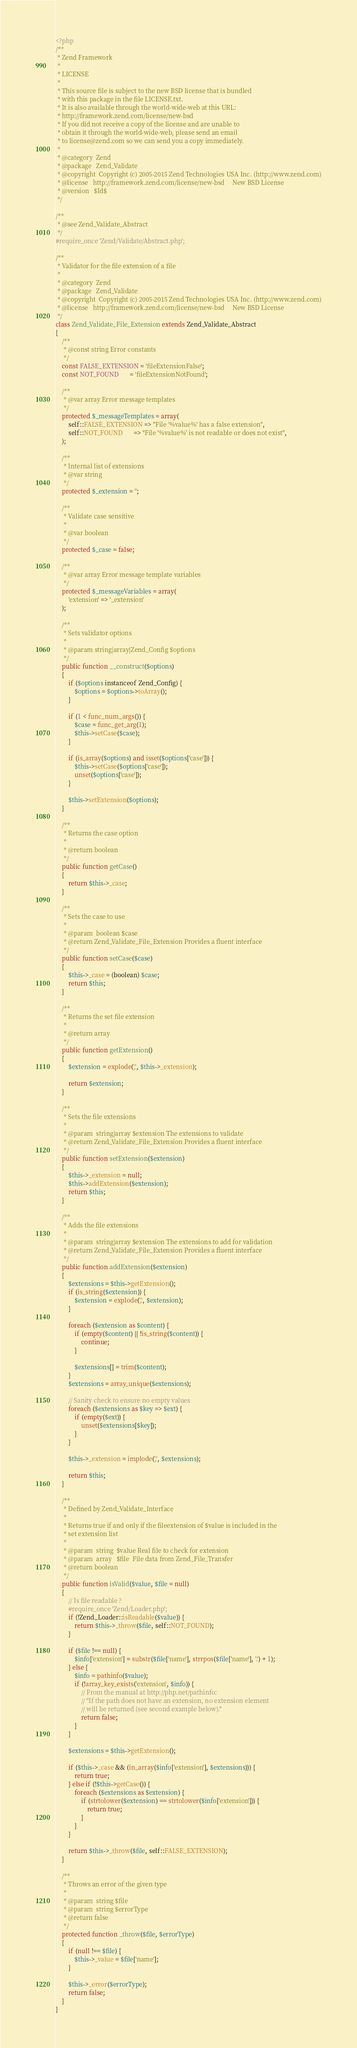Convert code to text. <code><loc_0><loc_0><loc_500><loc_500><_PHP_><?php
/**
 * Zend Framework
 *
 * LICENSE
 *
 * This source file is subject to the new BSD license that is bundled
 * with this package in the file LICENSE.txt.
 * It is also available through the world-wide-web at this URL:
 * http://framework.zend.com/license/new-bsd
 * If you did not receive a copy of the license and are unable to
 * obtain it through the world-wide-web, please send an email
 * to license@zend.com so we can send you a copy immediately.
 *
 * @category  Zend
 * @package   Zend_Validate
 * @copyright  Copyright (c) 2005-2015 Zend Technologies USA Inc. (http://www.zend.com)
 * @license   http://framework.zend.com/license/new-bsd     New BSD License
 * @version   $Id$
 */

/**
 * @see Zend_Validate_Abstract
 */
#require_once 'Zend/Validate/Abstract.php';

/**
 * Validator for the file extension of a file
 *
 * @category  Zend
 * @package   Zend_Validate
 * @copyright  Copyright (c) 2005-2015 Zend Technologies USA Inc. (http://www.zend.com)
 * @license   http://framework.zend.com/license/new-bsd     New BSD License
 */
class Zend_Validate_File_Extension extends Zend_Validate_Abstract
{
    /**
     * @const string Error constants
     */
    const FALSE_EXTENSION = 'fileExtensionFalse';
    const NOT_FOUND       = 'fileExtensionNotFound';

    /**
     * @var array Error message templates
     */
    protected $_messageTemplates = array(
        self::FALSE_EXTENSION => "File '%value%' has a false extension",
        self::NOT_FOUND       => "File '%value%' is not readable or does not exist",
    );

    /**
     * Internal list of extensions
     * @var string
     */
    protected $_extension = '';

    /**
     * Validate case sensitive
     *
     * @var boolean
     */
    protected $_case = false;

    /**
     * @var array Error message template variables
     */
    protected $_messageVariables = array(
        'extension' => '_extension'
    );

    /**
     * Sets validator options
     *
     * @param string|array|Zend_Config $options
     */
    public function __construct($options)
    {
        if ($options instanceof Zend_Config) {
            $options = $options->toArray();
        }

        if (1 < func_num_args()) {
            $case = func_get_arg(1);
            $this->setCase($case);
        }

        if (is_array($options) and isset($options['case'])) {
            $this->setCase($options['case']);
            unset($options['case']);
        }

        $this->setExtension($options);
    }

    /**
     * Returns the case option
     *
     * @return boolean
     */
    public function getCase()
    {
        return $this->_case;
    }

    /**
     * Sets the case to use
     *
     * @param  boolean $case
     * @return Zend_Validate_File_Extension Provides a fluent interface
     */
    public function setCase($case)
    {
        $this->_case = (boolean) $case;
        return $this;
    }

    /**
     * Returns the set file extension
     *
     * @return array
     */
    public function getExtension()
    {
        $extension = explode(',', $this->_extension);

        return $extension;
    }

    /**
     * Sets the file extensions
     *
     * @param  string|array $extension The extensions to validate
     * @return Zend_Validate_File_Extension Provides a fluent interface
     */
    public function setExtension($extension)
    {
        $this->_extension = null;
        $this->addExtension($extension);
        return $this;
    }

    /**
     * Adds the file extensions
     *
     * @param  string|array $extension The extensions to add for validation
     * @return Zend_Validate_File_Extension Provides a fluent interface
     */
    public function addExtension($extension)
    {
        $extensions = $this->getExtension();
        if (is_string($extension)) {
            $extension = explode(',', $extension);
        }

        foreach ($extension as $content) {
            if (empty($content) || !is_string($content)) {
                continue;
            }

            $extensions[] = trim($content);
        }
        $extensions = array_unique($extensions);

        // Sanity check to ensure no empty values
        foreach ($extensions as $key => $ext) {
            if (empty($ext)) {
                unset($extensions[$key]);
            }
        }

        $this->_extension = implode(',', $extensions);

        return $this;
    }

    /**
     * Defined by Zend_Validate_Interface
     *
     * Returns true if and only if the fileextension of $value is included in the
     * set extension list
     *
     * @param  string  $value Real file to check for extension
     * @param  array   $file  File data from Zend_File_Transfer
     * @return boolean
     */
    public function isValid($value, $file = null)
    {
        // Is file readable ?
        #require_once 'Zend/Loader.php';
        if (!Zend_Loader::isReadable($value)) {
            return $this->_throw($file, self::NOT_FOUND);
        }

        if ($file !== null) {
            $info['extension'] = substr($file['name'], strrpos($file['name'], '.') + 1);
        } else {
            $info = pathinfo($value);
            if (!array_key_exists('extension', $info)) {
                // From the manual at http://php.net/pathinfo:
                // "If the path does not have an extension, no extension element
                // will be returned (see second example below)."
                return false;
            }
        }

        $extensions = $this->getExtension();

        if ($this->_case && (in_array($info['extension'], $extensions))) {
            return true;
        } else if (!$this->getCase()) {
            foreach ($extensions as $extension) {
                if (strtolower($extension) == strtolower($info['extension'])) {
                    return true;
                }
            }
        }

        return $this->_throw($file, self::FALSE_EXTENSION);
    }

    /**
     * Throws an error of the given type
     *
     * @param  string $file
     * @param  string $errorType
     * @return false
     */
    protected function _throw($file, $errorType)
    {
        if (null !== $file) {
            $this->_value = $file['name'];
        }

        $this->_error($errorType);
        return false;
    }
}
</code> 